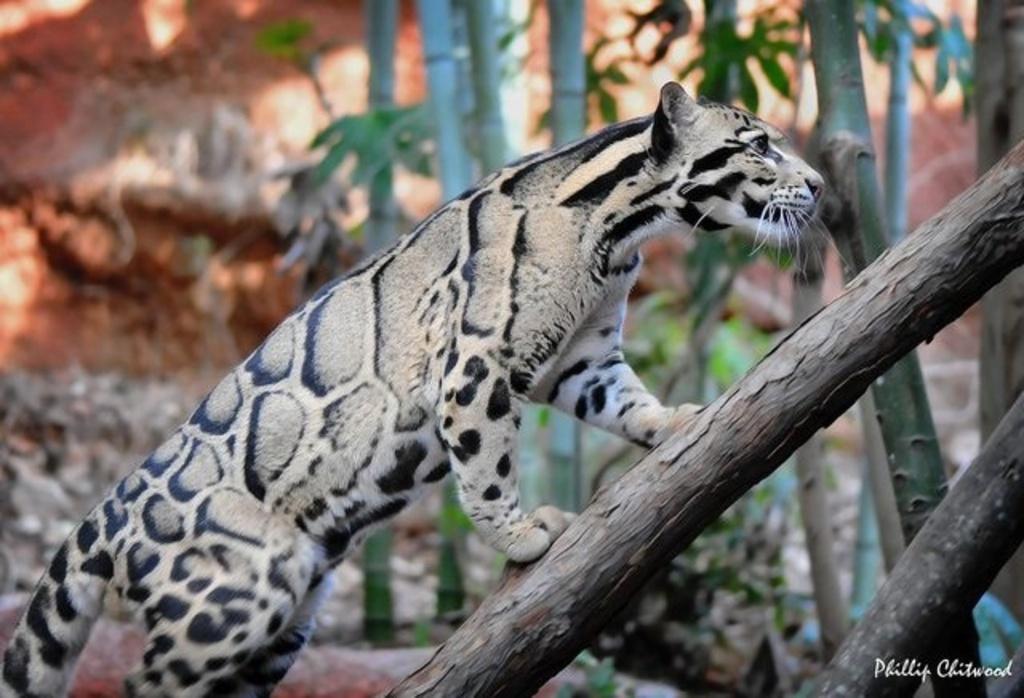Can you describe this image briefly? In this image we can see a animal on the tree branch. In the background of the image there are trees and stones. 